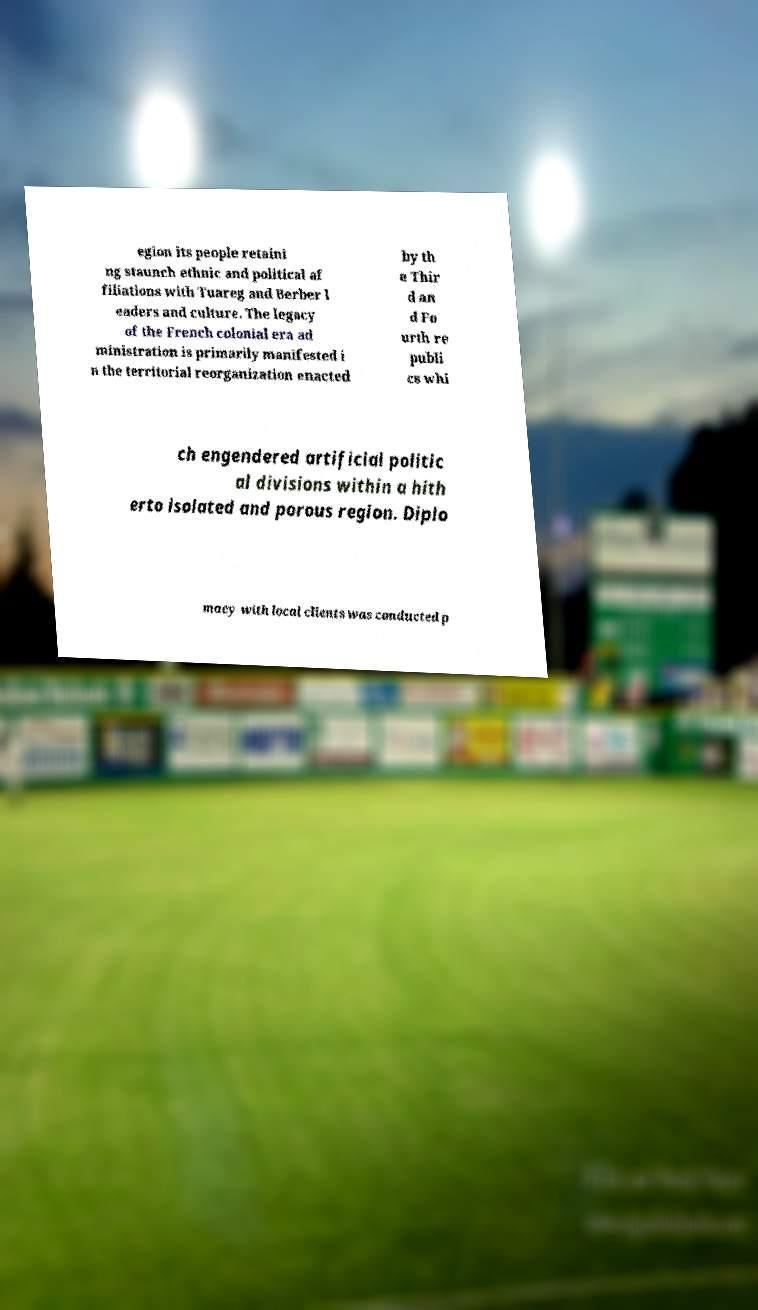Can you accurately transcribe the text from the provided image for me? egion its people retaini ng staunch ethnic and political af filiations with Tuareg and Berber l eaders and culture. The legacy of the French colonial era ad ministration is primarily manifested i n the territorial reorganization enacted by th e Thir d an d Fo urth re publi cs whi ch engendered artificial politic al divisions within a hith erto isolated and porous region. Diplo macy with local clients was conducted p 